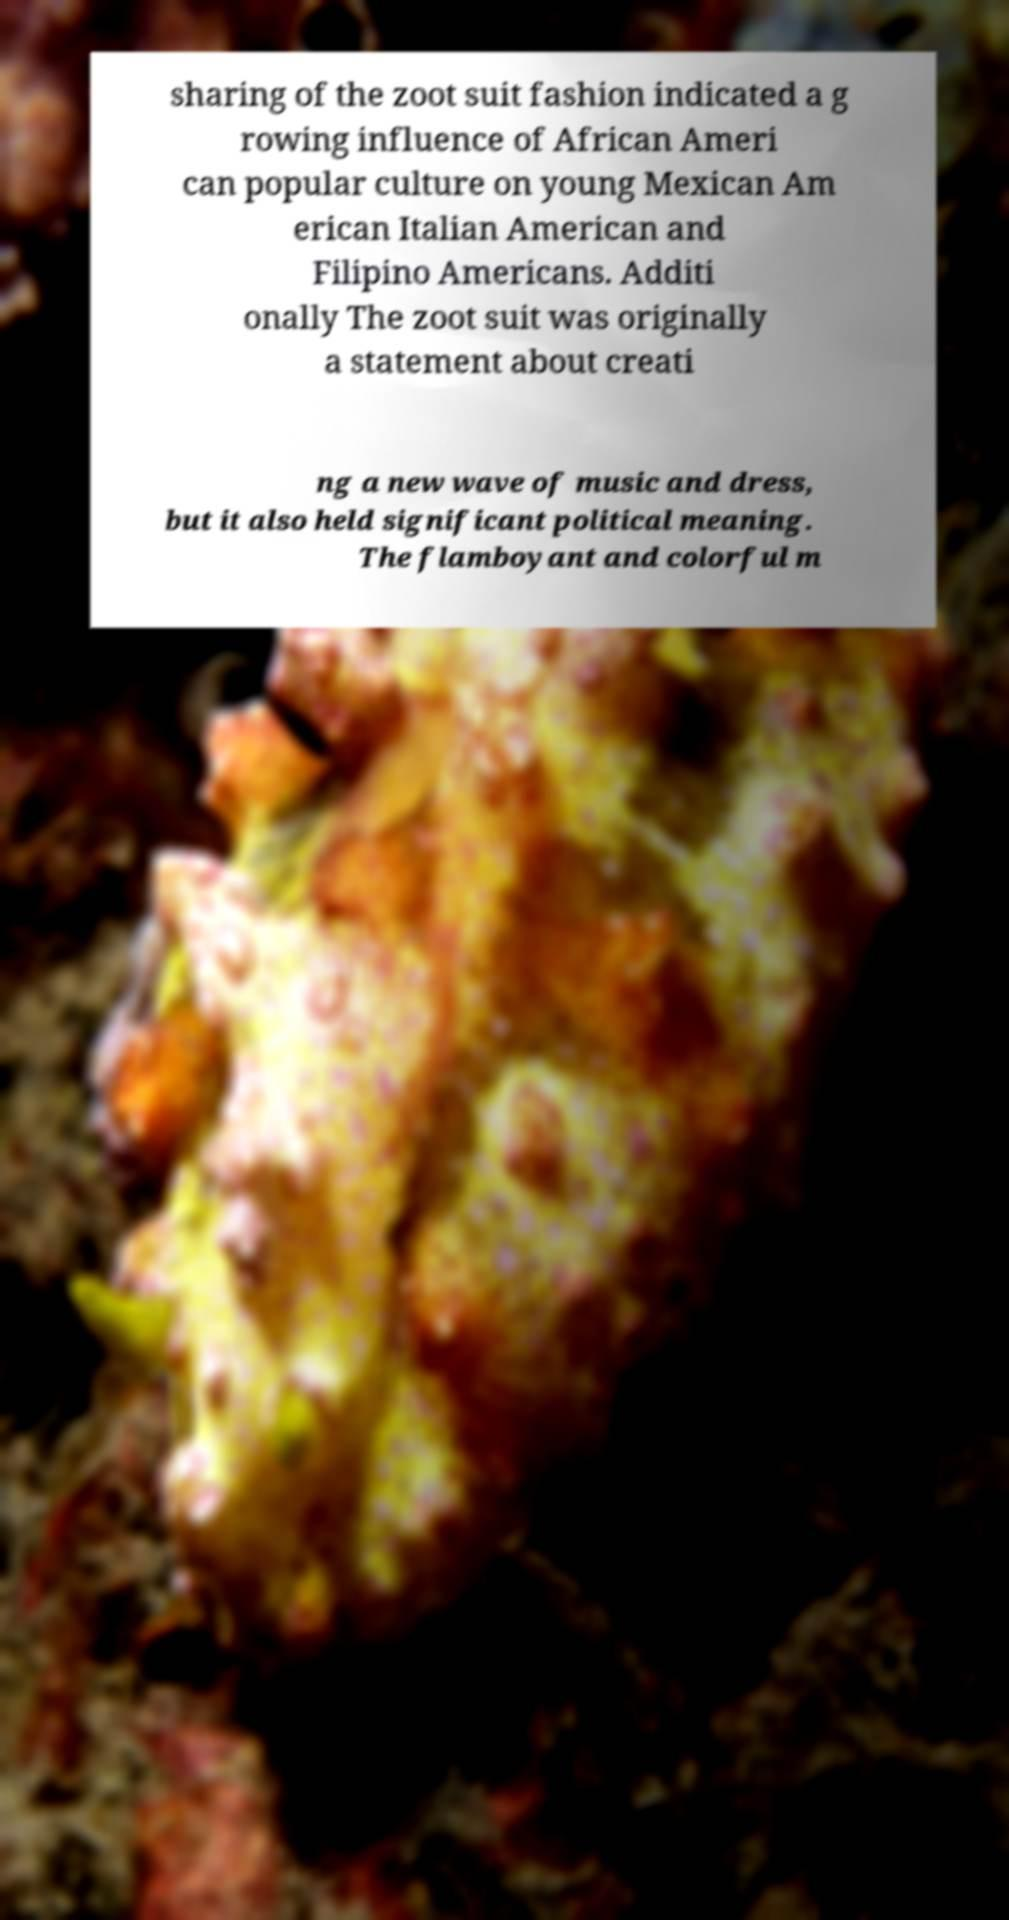Can you accurately transcribe the text from the provided image for me? sharing of the zoot suit fashion indicated a g rowing influence of African Ameri can popular culture on young Mexican Am erican Italian American and Filipino Americans. Additi onally The zoot suit was originally a statement about creati ng a new wave of music and dress, but it also held significant political meaning. The flamboyant and colorful m 